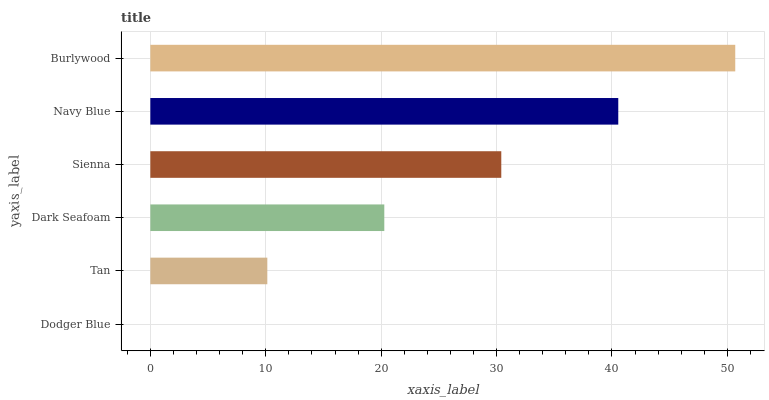Is Dodger Blue the minimum?
Answer yes or no. Yes. Is Burlywood the maximum?
Answer yes or no. Yes. Is Tan the minimum?
Answer yes or no. No. Is Tan the maximum?
Answer yes or no. No. Is Tan greater than Dodger Blue?
Answer yes or no. Yes. Is Dodger Blue less than Tan?
Answer yes or no. Yes. Is Dodger Blue greater than Tan?
Answer yes or no. No. Is Tan less than Dodger Blue?
Answer yes or no. No. Is Sienna the high median?
Answer yes or no. Yes. Is Dark Seafoam the low median?
Answer yes or no. Yes. Is Navy Blue the high median?
Answer yes or no. No. Is Dodger Blue the low median?
Answer yes or no. No. 